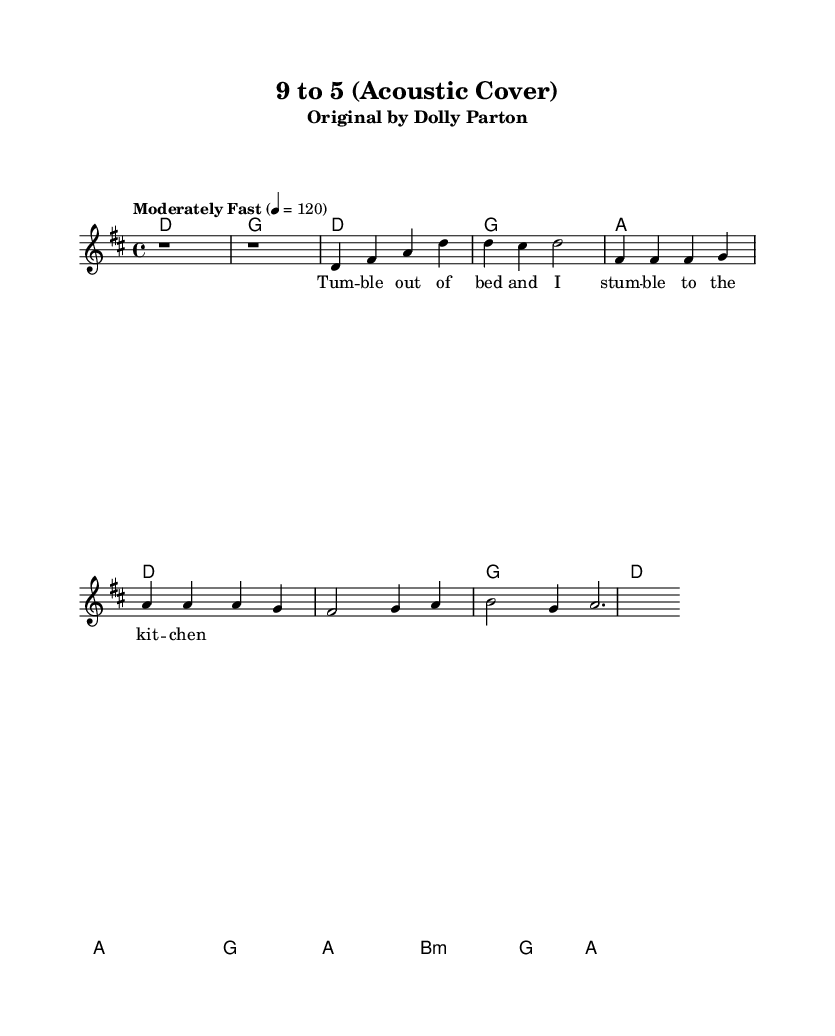What is the key signature of this music? The key signature is D major, which has two sharps (F# and C#). This can be identified by looking at the key signature marking at the beginning of the staff, indicating the tonal center of the piece.
Answer: D major What is the time signature of this music? The time signature is 4/4. This is found by looking at the time signature marking at the beginning of the staff, indicating that there are four beats per measure, and each quarter note receives one beat.
Answer: 4/4 What is the tempo marking of this piece? The tempo marking is "Moderately Fast" set at 120 beats per minute. This can be seen in the tempo indication just above the staff, giving the performer guidance on the speed at which to play the music.
Answer: Moderately Fast How many measures are there in the verse? There are four measures in the verse. By counting each section in the melody and harmonies, you can observe where the lyrics align and determine the measure count relative to the verse section.
Answer: Four What chord follows the D chord in the verse? The chord that follows the D chord in the verse is G. By analyzing the chords in the harmonies section of the sheet music, you can trace the progression to see that after the D chord comes the G chord.
Answer: G What is the last chord of the bridge? The last chord of the bridge is A. In the harmonies section, the bridge is defined, and the final chord is clearly indicated as A after going through the initial bridge progression.
Answer: A Which section contains the lyrics "Tum - ble out of bed and I stum - ble to the kit - chen"? The section containing these lyrics is the verse. By reading through the lyrics aligned with the melody and observing their placement, it becomes clear they belong to the verse section.
Answer: Verse 